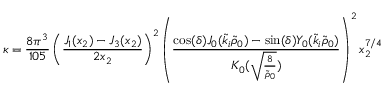<formula> <loc_0><loc_0><loc_500><loc_500>\kappa = \frac { 8 \pi ^ { 3 } } { 1 0 5 } \left ( \frac { J _ { 1 } ( x _ { 2 } ) - J _ { 3 } ( x _ { 2 } ) } { 2 x _ { 2 } } \right ) ^ { 2 } \left ( \frac { \cos ( \delta ) J _ { 0 } ( \tilde { k } _ { i } \tilde { \rho } _ { 0 } ) - \sin ( \delta ) Y _ { 0 } ( \tilde { k } _ { i } \tilde { \rho } _ { 0 } ) } { K _ { 0 } ( \sqrt { \frac { 8 } { \tilde { \rho } _ { 0 } } } ) } \right ) ^ { 2 } x _ { 2 } ^ { 7 / 4 }</formula> 